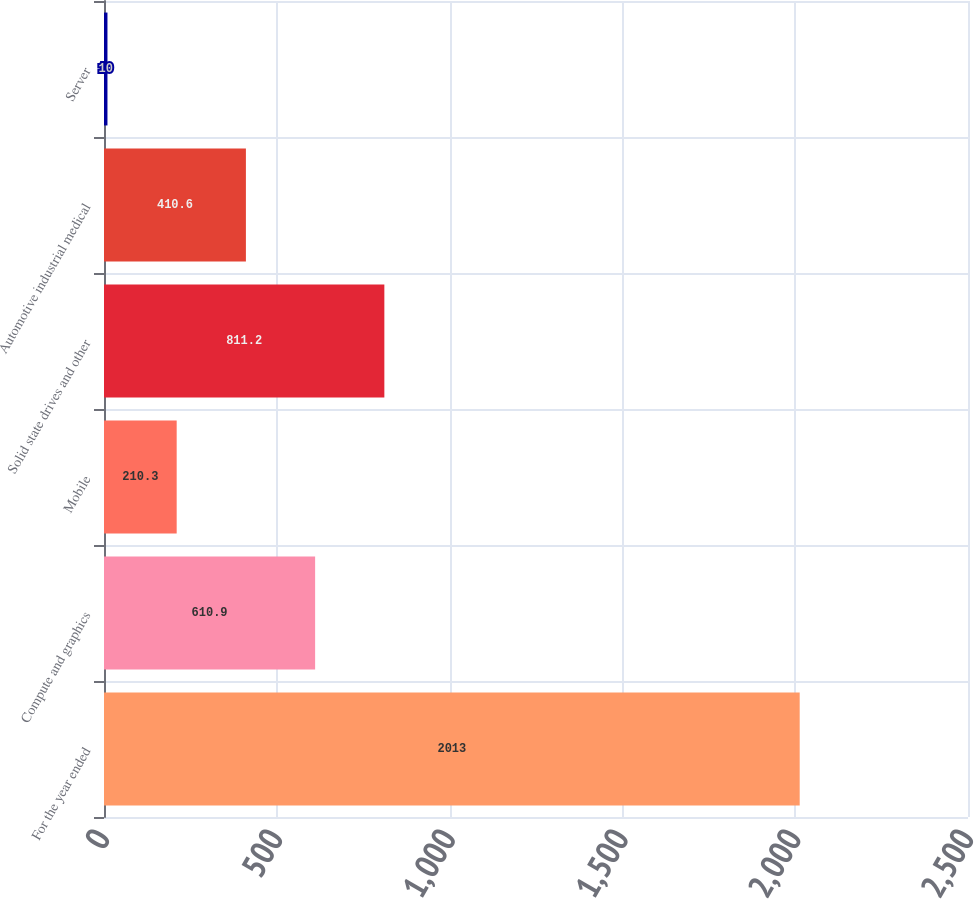Convert chart. <chart><loc_0><loc_0><loc_500><loc_500><bar_chart><fcel>For the year ended<fcel>Compute and graphics<fcel>Mobile<fcel>Solid state drives and other<fcel>Automotive industrial medical<fcel>Server<nl><fcel>2013<fcel>610.9<fcel>210.3<fcel>811.2<fcel>410.6<fcel>10<nl></chart> 